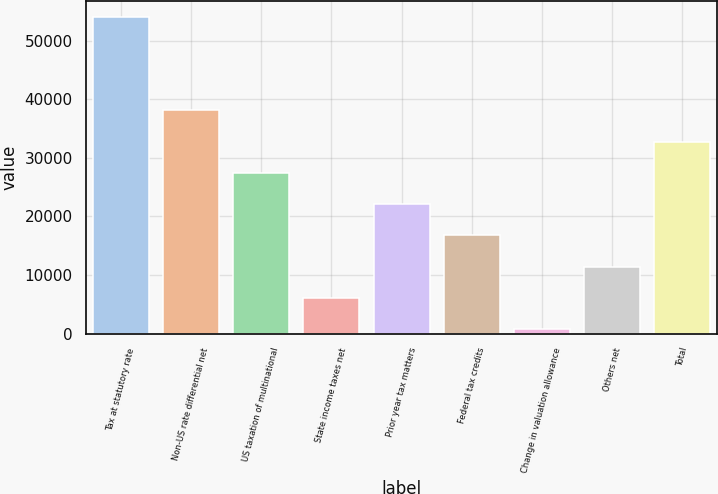<chart> <loc_0><loc_0><loc_500><loc_500><bar_chart><fcel>Tax at statutory rate<fcel>Non-US rate differential net<fcel>US taxation of multinational<fcel>State income taxes net<fcel>Prior year tax matters<fcel>Federal tax credits<fcel>Change in valuation allowance<fcel>Others net<fcel>Total<nl><fcel>54114<fcel>38107.5<fcel>27436.5<fcel>6094.5<fcel>22101<fcel>16765.5<fcel>759<fcel>11430<fcel>32772<nl></chart> 